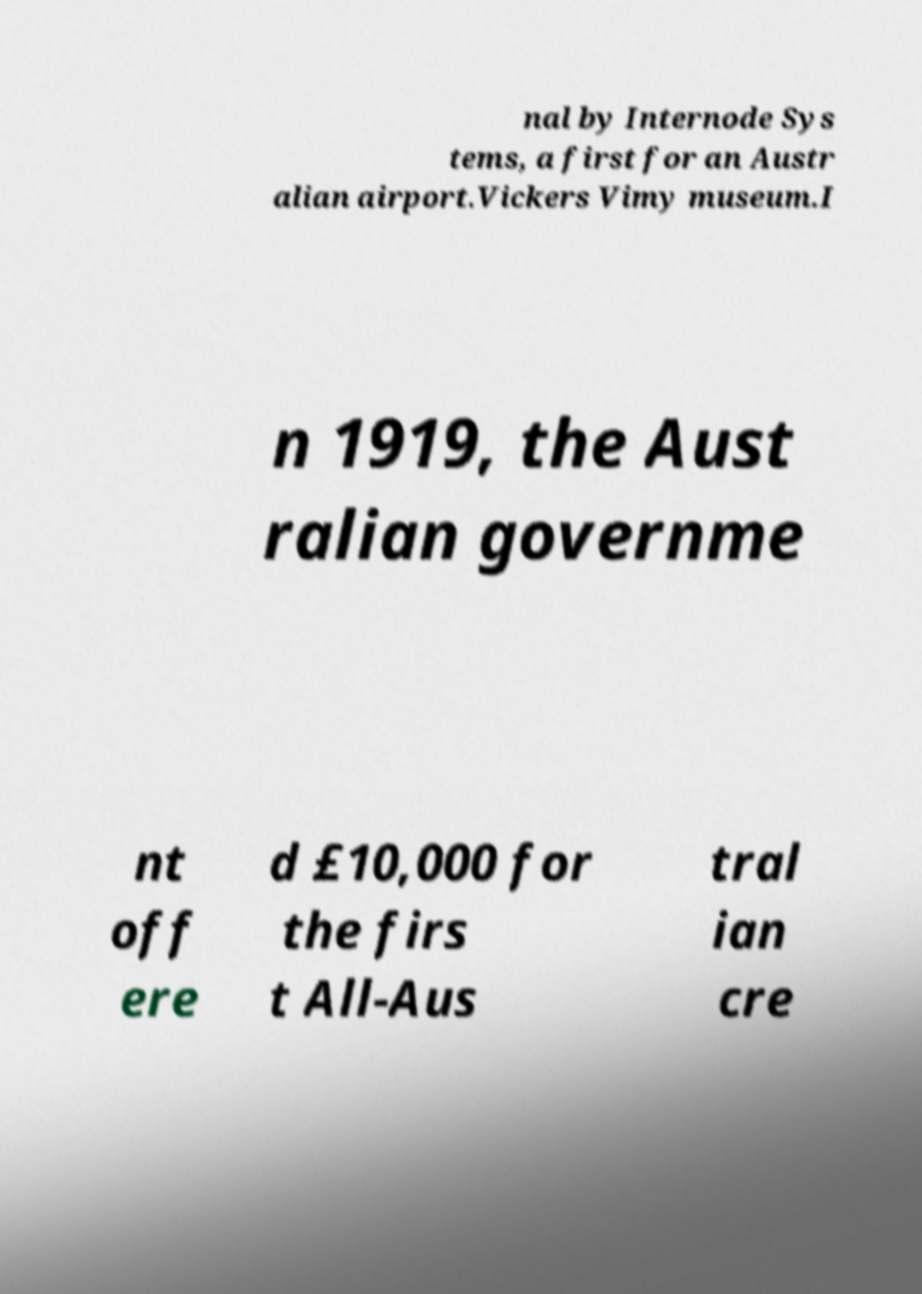Please read and relay the text visible in this image. What does it say? nal by Internode Sys tems, a first for an Austr alian airport.Vickers Vimy museum.I n 1919, the Aust ralian governme nt off ere d £10,000 for the firs t All-Aus tral ian cre 